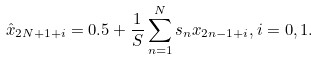<formula> <loc_0><loc_0><loc_500><loc_500>\hat { x } _ { 2 N + 1 + i } = 0 . 5 + \frac { 1 } { S } \sum _ { n = 1 } ^ { N } s _ { n } x _ { 2 n - 1 + i } , i = 0 , 1 .</formula> 